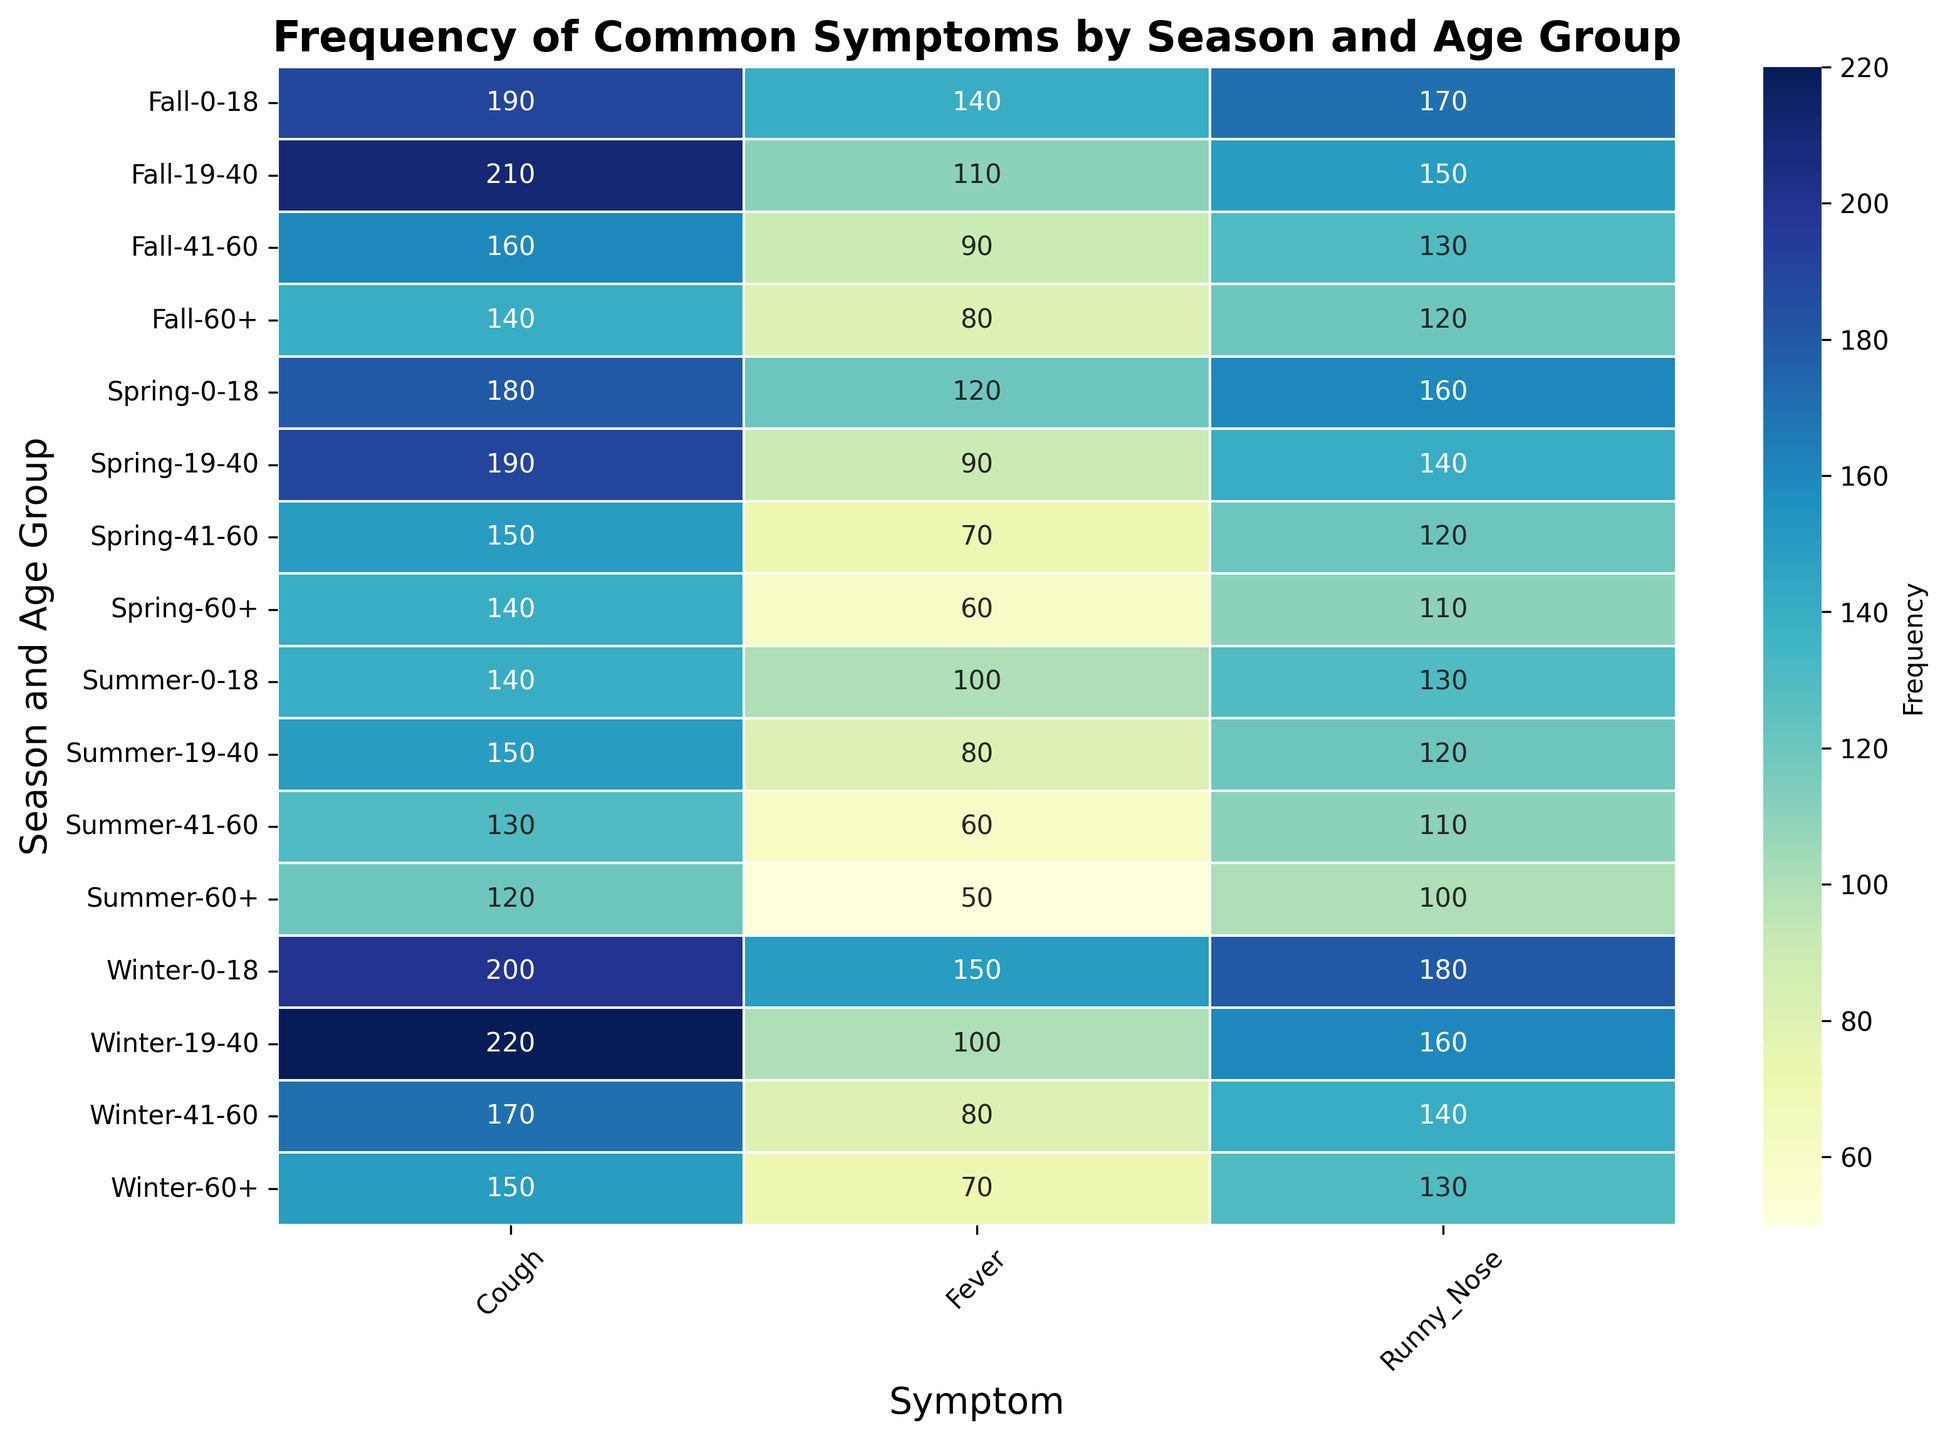What's the most frequently reported symptom in the winter season for the 0-18 age group? Refer to the heatmap, look for the winter season in the 0-18 age group row. The highest frequency for symptoms Fever, Cough, and Runny Nose in this row are 150, 200, and 180 respectively.
Answer: Cough Which age group reports the highest frequency of coughing symptoms in the spring season? Look at the heatmap and identify the spring season rows. Compare the Cough frequencies across age groups 0-18, 19-40, 41-60, and 60+. These values are 180, 190, 150, 140 respectively.
Answer: 19-40 Compare the frequency of fever symptoms between summer and fall for the 19-40 age group. Which season has a higher frequency? Refer to the heatmap and find the fever frequencies for the 19-40 age group in summer and fall rows. The values are 80 for summer and 110 for fall.
Answer: Fall How does the frequency of runny nose in the fall for the 0-18 age group compare to the frequency in the winter for the 60+ age group? From the heatmap, find the runny nose frequencies for the fall in the 0-18 age group and winter in the 60+ age group. These values are 170 and 130 respectively. Compare them.
Answer: Fall 0-18 is higher What's the average frequency of fever reported in the 41-60 age group across all seasons? Locate the fever frequencies for the 41-60 age group across winter, spring, summer, and fall. These values are 80, 70, 60, 90 respectively. Add them: 80 + 70 + 60 + 90 = 300, then divide by 4.
Answer: 75 In which season is the cough frequency highest for the 60+ age group? Identify the cough frequencies for the 60+ age group in winter, spring, summer, and fall. These frequencies are 150, 140, 120, 140. The highest is in winter.
Answer: Winter What is the total frequency of runny nose reported in the summer season across all age groups? Locate the runny nose frequencies for summer for all age groups: 0-18, 19-40, 41-60, and 60+. These values are 130, 120, 110, and 100 respectively. Add them: 130 + 120 + 110 + 100.
Answer: 460 